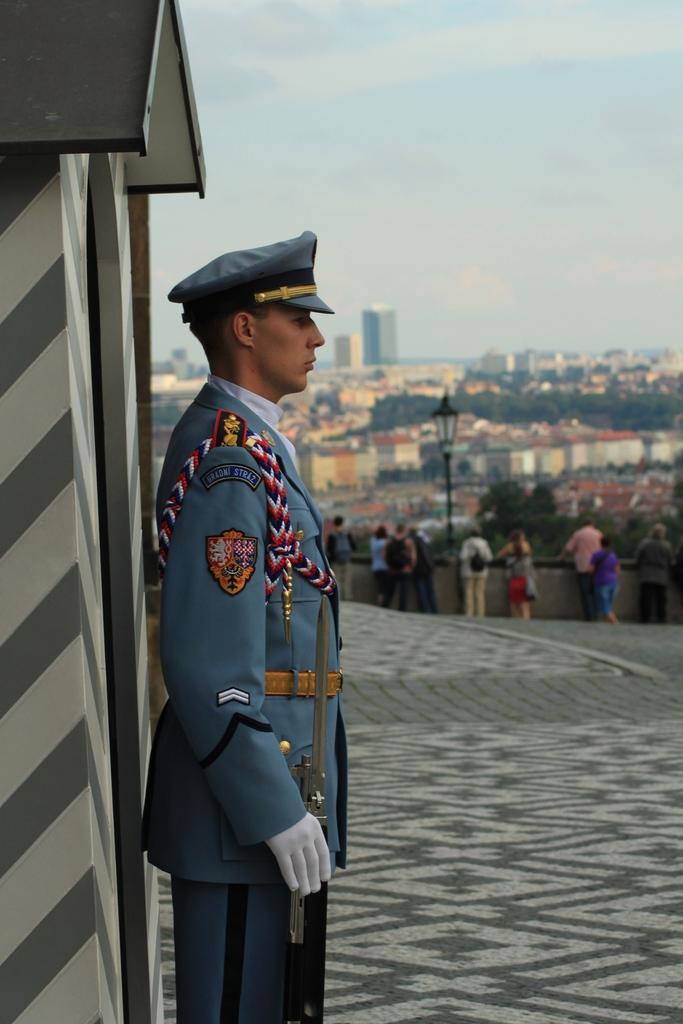Can you describe this image briefly? In this picture we can see the security man wearing a grey dress and standing. Behind we can see some people standing near the wall. In the background there are some buildings and houses. Above there is a sky. 